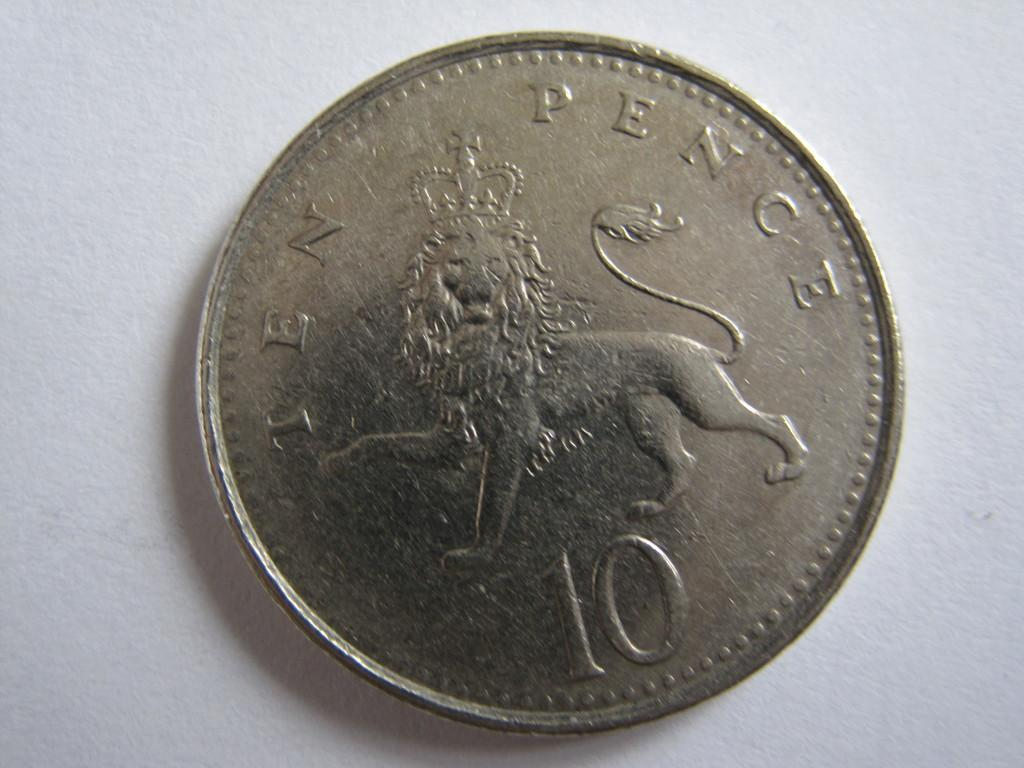<image>
Render a clear and concise summary of the photo. A silver piece coin has a lion symbol with the number 10 at the bottom and the word pence written on top. 